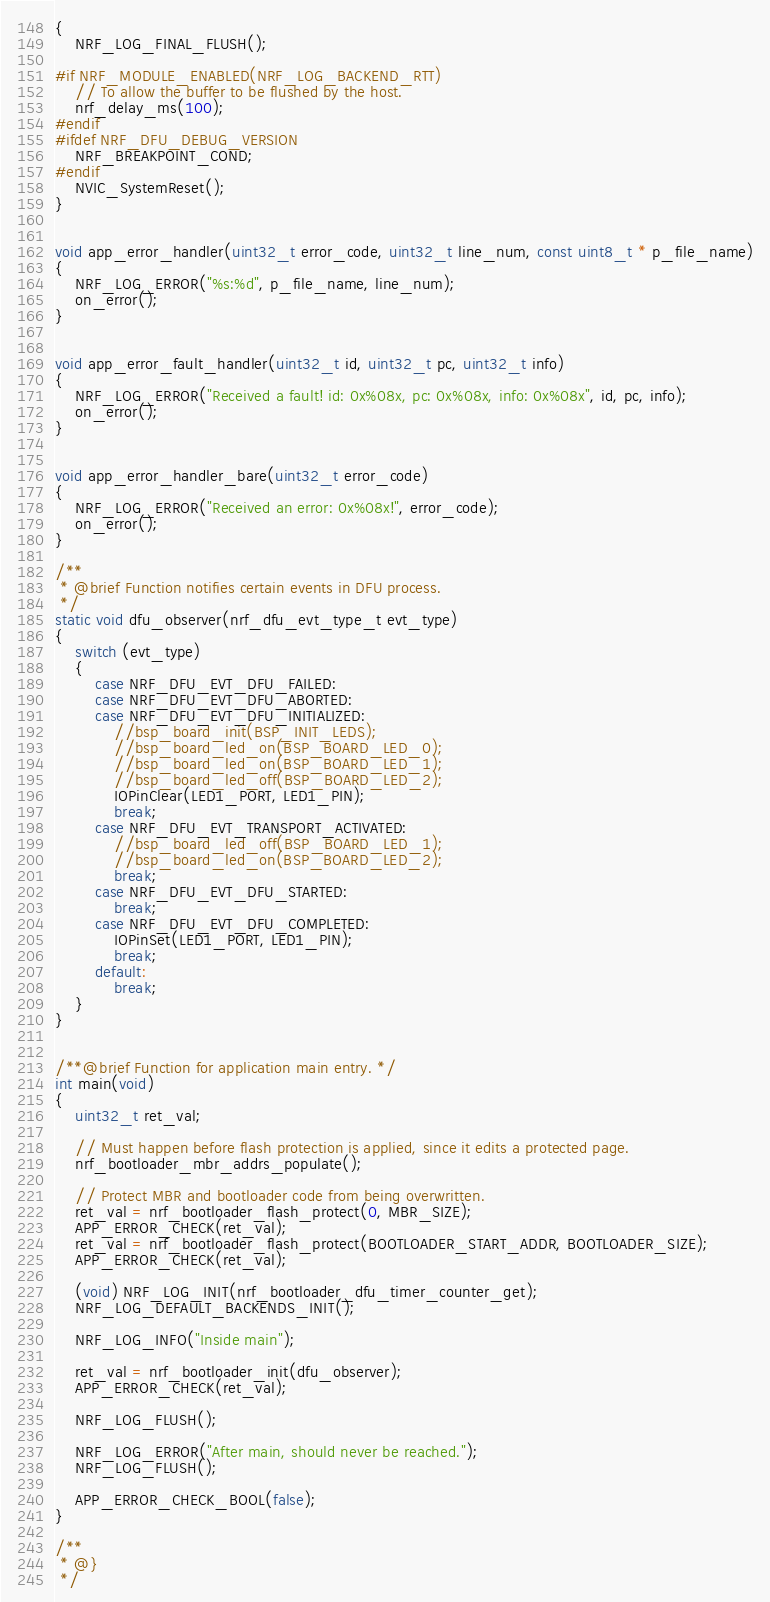<code> <loc_0><loc_0><loc_500><loc_500><_C_>{
    NRF_LOG_FINAL_FLUSH();

#if NRF_MODULE_ENABLED(NRF_LOG_BACKEND_RTT)
    // To allow the buffer to be flushed by the host.
    nrf_delay_ms(100);
#endif
#ifdef NRF_DFU_DEBUG_VERSION
    NRF_BREAKPOINT_COND;
#endif
    NVIC_SystemReset();
}


void app_error_handler(uint32_t error_code, uint32_t line_num, const uint8_t * p_file_name)
{
    NRF_LOG_ERROR("%s:%d", p_file_name, line_num);
    on_error();
}


void app_error_fault_handler(uint32_t id, uint32_t pc, uint32_t info)
{
    NRF_LOG_ERROR("Received a fault! id: 0x%08x, pc: 0x%08x, info: 0x%08x", id, pc, info);
    on_error();
}


void app_error_handler_bare(uint32_t error_code)
{
    NRF_LOG_ERROR("Received an error: 0x%08x!", error_code);
    on_error();
}

/**
 * @brief Function notifies certain events in DFU process.
 */
static void dfu_observer(nrf_dfu_evt_type_t evt_type)
{
    switch (evt_type)
    {
        case NRF_DFU_EVT_DFU_FAILED:
        case NRF_DFU_EVT_DFU_ABORTED:
        case NRF_DFU_EVT_DFU_INITIALIZED:
            //bsp_board_init(BSP_INIT_LEDS);
            //bsp_board_led_on(BSP_BOARD_LED_0);
            //bsp_board_led_on(BSP_BOARD_LED_1);
            //bsp_board_led_off(BSP_BOARD_LED_2);
        	IOPinClear(LED1_PORT, LED1_PIN);
            break;
        case NRF_DFU_EVT_TRANSPORT_ACTIVATED:
            //bsp_board_led_off(BSP_BOARD_LED_1);
            //bsp_board_led_on(BSP_BOARD_LED_2);
            break;
        case NRF_DFU_EVT_DFU_STARTED:
            break;
        case NRF_DFU_EVT_DFU_COMPLETED:
        	IOPinSet(LED1_PORT, LED1_PIN);
        	break;
        default:
            break;
    }
}


/**@brief Function for application main entry. */
int main(void)
{
    uint32_t ret_val;

    // Must happen before flash protection is applied, since it edits a protected page.
    nrf_bootloader_mbr_addrs_populate();

    // Protect MBR and bootloader code from being overwritten.
    ret_val = nrf_bootloader_flash_protect(0, MBR_SIZE);
    APP_ERROR_CHECK(ret_val);
    ret_val = nrf_bootloader_flash_protect(BOOTLOADER_START_ADDR, BOOTLOADER_SIZE);
    APP_ERROR_CHECK(ret_val);

    (void) NRF_LOG_INIT(nrf_bootloader_dfu_timer_counter_get);
    NRF_LOG_DEFAULT_BACKENDS_INIT();

    NRF_LOG_INFO("Inside main");

    ret_val = nrf_bootloader_init(dfu_observer);
    APP_ERROR_CHECK(ret_val);

    NRF_LOG_FLUSH();

    NRF_LOG_ERROR("After main, should never be reached.");
    NRF_LOG_FLUSH();

    APP_ERROR_CHECK_BOOL(false);
}

/**
 * @}
 */
</code> 